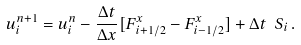Convert formula to latex. <formula><loc_0><loc_0><loc_500><loc_500>u _ { i } ^ { n + 1 } = u _ { i } ^ { n } - \frac { \Delta t } { \Delta x } [ F _ { i + 1 / 2 } ^ { x } - F _ { i - 1 / 2 } ^ { x } ] + \Delta t \ S _ { i } \, .</formula> 